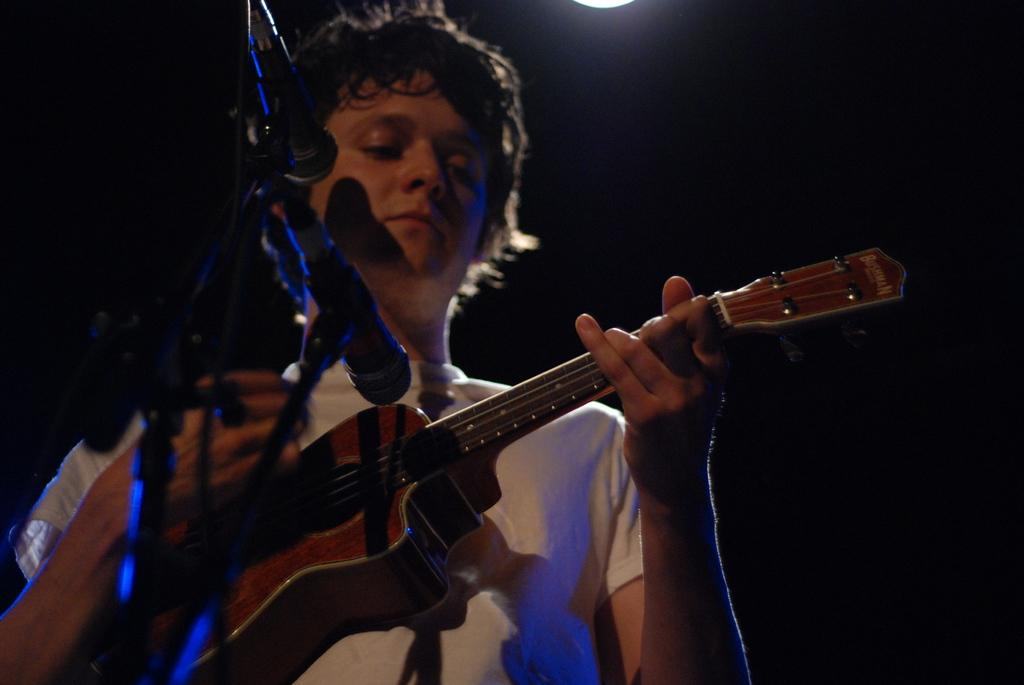What is the person in the image doing? The person is playing the guitar. What is the person wearing in the image? The person is wearing a white t-shirt. What instrument is the person holding in the image? The person is holding a guitar. What equipment is set up in front of the person? There are mics and stands in front of the person. What type of vegetable is being used as a slide on the guitar in the image? There is no vegetable being used as a slide on the guitar in the image; the person is simply playing the guitar. Can you tell me how much friction the monkey is causing on the guitar strings in the image? There is no monkey present in the image, so it is not possible to determine the amount of friction caused by a monkey on the guitar strings. 